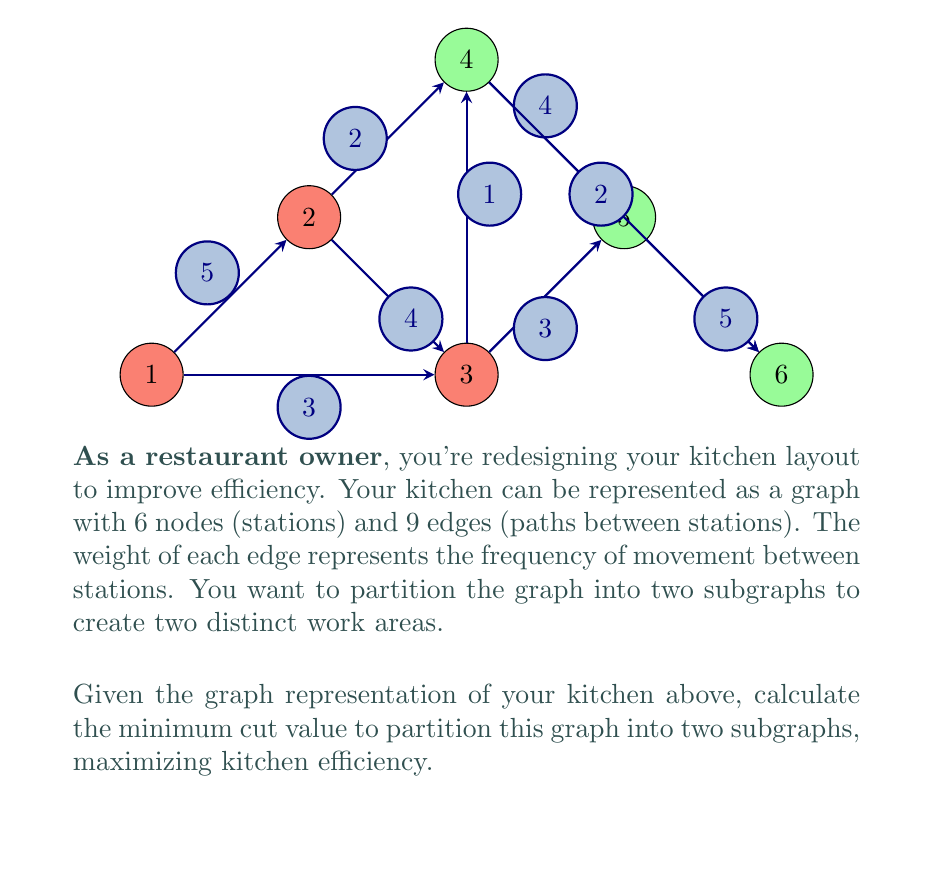Solve this math problem. To solve this problem, we need to find the minimum cut that partitions the graph into two subgraphs. The cut value is the sum of the weights of the edges that are removed to create the partition.

Step 1: Identify all possible partitions of the graph into two subgraphs.

Step 2: For each partition, calculate the cut value by summing the weights of the edges that cross between the two subgraphs.

Step 3: Find the partition with the minimum cut value.

Let's examine some key partitions:

1. {1,2,3} and {4,5,6}:
   Cut edges: (2,4), (3,4), (3,5)
   Cut value: 3 + 4 + 2 = 9

2. {1,2,3,4} and {5,6}:
   Cut edges: (3,5), (4,5)
   Cut value: 2 + 5 = 7

3. {1,2} and {3,4,5,6}:
   Cut edges: (1,3), (2,3), (2,4)
   Cut value: 3 + 4 + 2 = 9

4. {1,2,4} and {3,5,6}:
   Cut edges: (1,3), (2,3), (3,4), (4,5)
   Cut value: 3 + 1 + 4 + 5 = 13

After examining all possible partitions, we find that the minimum cut value is 7, achieved by partitioning the graph into {1,2,3,4} and {5,6}.

This partition minimizes the frequency of movement between the two areas, thus maximizing kitchen efficiency.
Answer: 7 